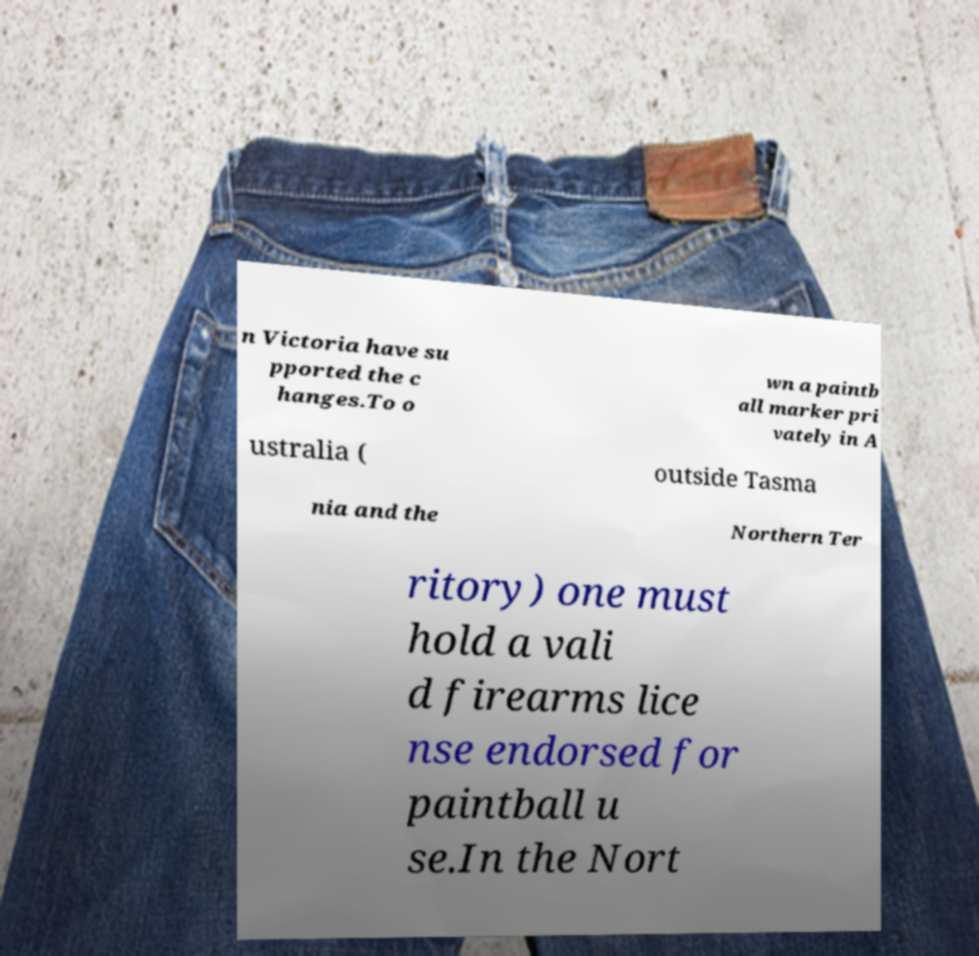I need the written content from this picture converted into text. Can you do that? n Victoria have su pported the c hanges.To o wn a paintb all marker pri vately in A ustralia ( outside Tasma nia and the Northern Ter ritory) one must hold a vali d firearms lice nse endorsed for paintball u se.In the Nort 